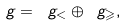<formula> <loc_0><loc_0><loc_500><loc_500>\ g = \ g _ { < } \oplus \ g _ { \geqslant } ,</formula> 